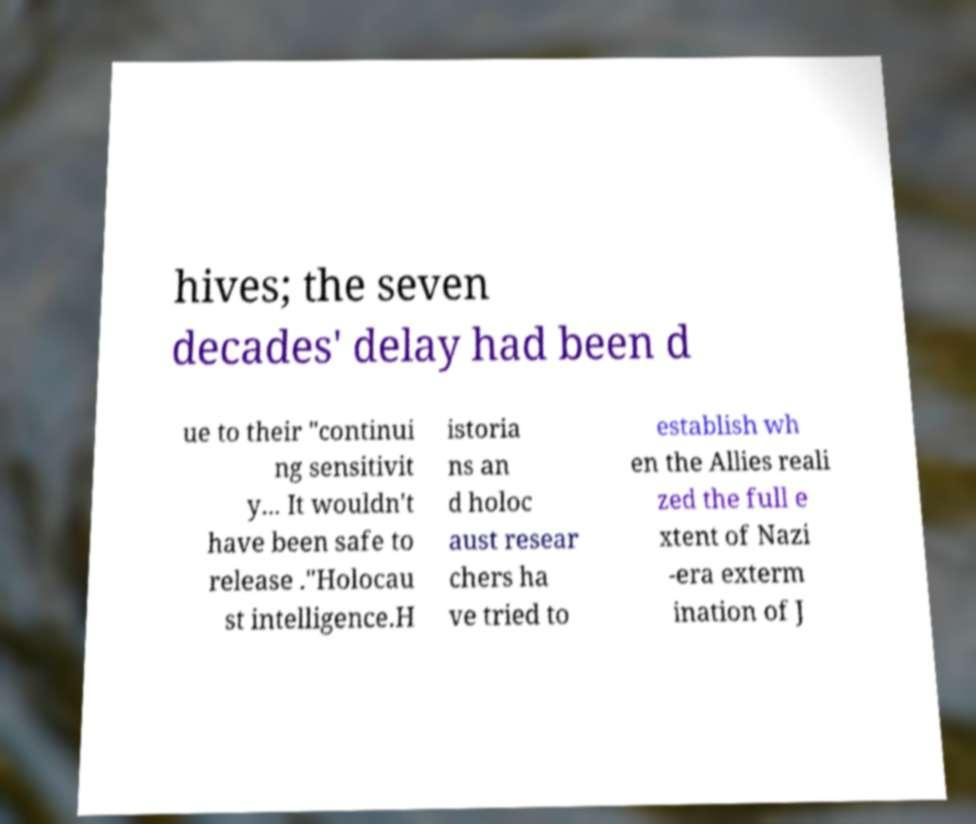I need the written content from this picture converted into text. Can you do that? hives; the seven decades' delay had been d ue to their "continui ng sensitivit y... It wouldn't have been safe to release ."Holocau st intelligence.H istoria ns an d holoc aust resear chers ha ve tried to establish wh en the Allies reali zed the full e xtent of Nazi -era exterm ination of J 